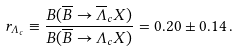Convert formula to latex. <formula><loc_0><loc_0><loc_500><loc_500>r _ { \Lambda _ { c } } \equiv \frac { B ( \overline { B } \rightarrow \overline { \Lambda } _ { c } X ) } { B ( \overline { B } \rightarrow \Lambda _ { c } X ) } = 0 . 2 0 \pm 0 . 1 4 \, .</formula> 